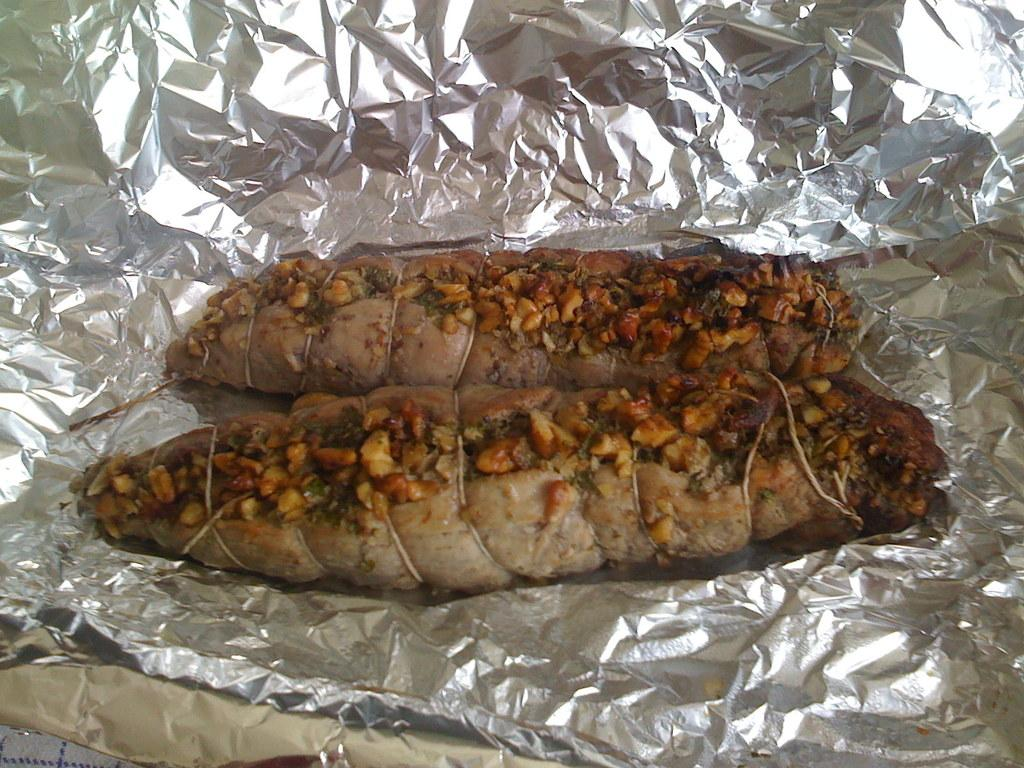What is present in the image related to eating? There is food in the image. How is the food presented or served? The food is on a paper. What type of chin can be seen supporting the food in the image? There is no chin present in the image; the food is on a paper. 